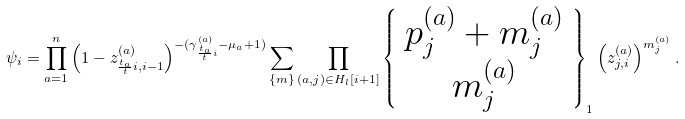<formula> <loc_0><loc_0><loc_500><loc_500>\psi _ { i } = \prod _ { a = 1 } ^ { n } \left ( 1 - z ^ { ( a ) } _ { \frac { t _ { a } } { t } i , i - 1 } \right ) ^ { - ( \gamma ^ { ( a ) } _ { \frac { t _ { a } } { t } i } - \mu _ { a } + 1 ) } \sum _ { \{ m \} } \prod _ { ( a , j ) \in H _ { l } [ i + 1 ] } \left \{ \begin{array} { c } p ^ { ( a ) } _ { j } + m ^ { ( a ) } _ { j } \\ m ^ { ( a ) } _ { j } \end{array} \right \} _ { 1 } \left ( z ^ { ( a ) } _ { j , i } \right ) ^ { m ^ { ( a ) } _ { j } } .</formula> 